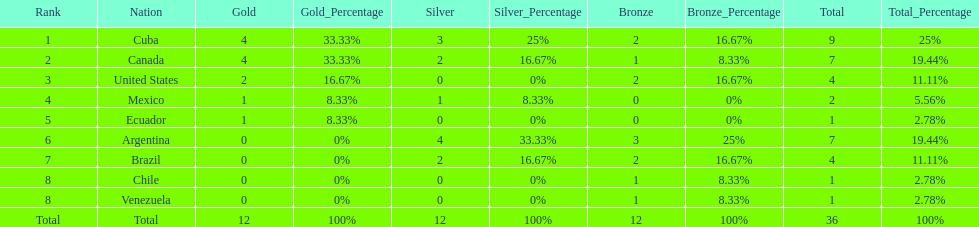Which is the only nation to win a gold medal and nothing else? Ecuador. 